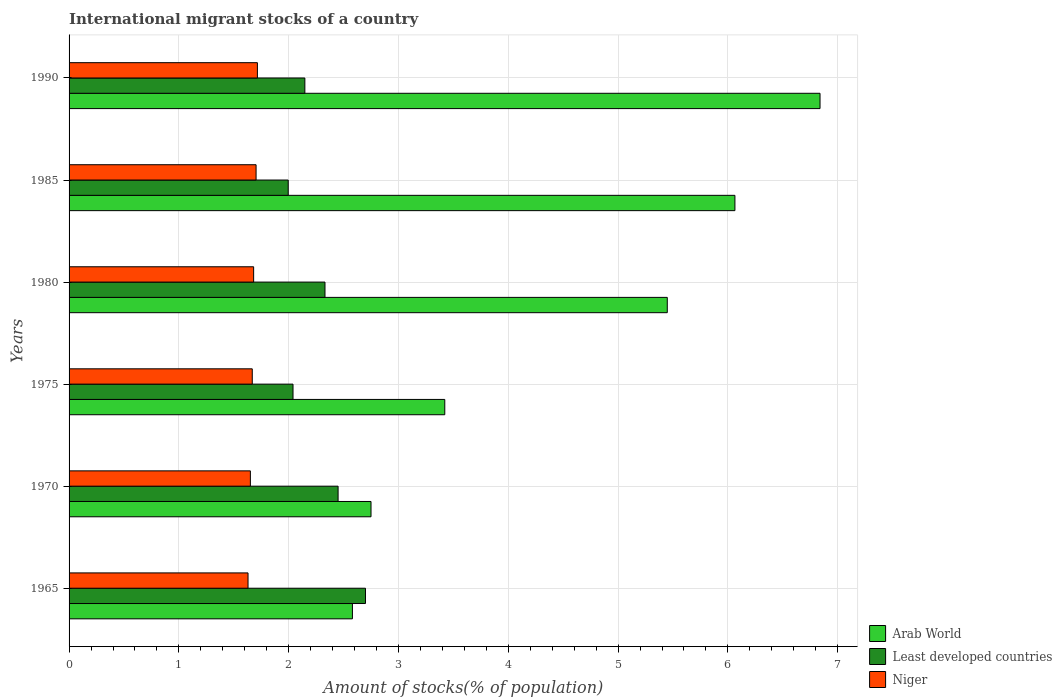How many different coloured bars are there?
Your response must be concise. 3. How many groups of bars are there?
Your answer should be very brief. 6. Are the number of bars per tick equal to the number of legend labels?
Offer a terse response. Yes. How many bars are there on the 1st tick from the bottom?
Make the answer very short. 3. What is the label of the 5th group of bars from the top?
Offer a terse response. 1970. What is the amount of stocks in in Arab World in 1990?
Provide a short and direct response. 6.84. Across all years, what is the maximum amount of stocks in in Arab World?
Ensure brevity in your answer.  6.84. Across all years, what is the minimum amount of stocks in in Least developed countries?
Provide a short and direct response. 2. In which year was the amount of stocks in in Least developed countries maximum?
Offer a terse response. 1965. In which year was the amount of stocks in in Least developed countries minimum?
Provide a short and direct response. 1985. What is the total amount of stocks in in Least developed countries in the graph?
Keep it short and to the point. 13.66. What is the difference between the amount of stocks in in Niger in 1985 and that in 1990?
Offer a very short reply. -0.01. What is the difference between the amount of stocks in in Niger in 1990 and the amount of stocks in in Arab World in 1975?
Provide a short and direct response. -1.71. What is the average amount of stocks in in Niger per year?
Provide a succinct answer. 1.67. In the year 1980, what is the difference between the amount of stocks in in Arab World and amount of stocks in in Least developed countries?
Ensure brevity in your answer.  3.12. What is the ratio of the amount of stocks in in Arab World in 1970 to that in 1980?
Offer a very short reply. 0.5. Is the difference between the amount of stocks in in Arab World in 1965 and 1985 greater than the difference between the amount of stocks in in Least developed countries in 1965 and 1985?
Ensure brevity in your answer.  No. What is the difference between the highest and the second highest amount of stocks in in Niger?
Provide a succinct answer. 0.01. What is the difference between the highest and the lowest amount of stocks in in Arab World?
Make the answer very short. 4.26. In how many years, is the amount of stocks in in Niger greater than the average amount of stocks in in Niger taken over all years?
Keep it short and to the point. 3. What does the 2nd bar from the top in 1985 represents?
Keep it short and to the point. Least developed countries. What does the 1st bar from the bottom in 1965 represents?
Provide a succinct answer. Arab World. How many bars are there?
Ensure brevity in your answer.  18. How many years are there in the graph?
Your answer should be very brief. 6. What is the difference between two consecutive major ticks on the X-axis?
Make the answer very short. 1. Where does the legend appear in the graph?
Your answer should be very brief. Bottom right. How many legend labels are there?
Provide a short and direct response. 3. How are the legend labels stacked?
Offer a terse response. Vertical. What is the title of the graph?
Your answer should be compact. International migrant stocks of a country. What is the label or title of the X-axis?
Your response must be concise. Amount of stocks(% of population). What is the label or title of the Y-axis?
Your answer should be very brief. Years. What is the Amount of stocks(% of population) of Arab World in 1965?
Offer a terse response. 2.58. What is the Amount of stocks(% of population) of Least developed countries in 1965?
Make the answer very short. 2.7. What is the Amount of stocks(% of population) in Niger in 1965?
Give a very brief answer. 1.63. What is the Amount of stocks(% of population) of Arab World in 1970?
Give a very brief answer. 2.75. What is the Amount of stocks(% of population) in Least developed countries in 1970?
Ensure brevity in your answer.  2.45. What is the Amount of stocks(% of population) of Niger in 1970?
Give a very brief answer. 1.65. What is the Amount of stocks(% of population) of Arab World in 1975?
Offer a terse response. 3.42. What is the Amount of stocks(% of population) of Least developed countries in 1975?
Your response must be concise. 2.04. What is the Amount of stocks(% of population) in Niger in 1975?
Offer a very short reply. 1.67. What is the Amount of stocks(% of population) of Arab World in 1980?
Keep it short and to the point. 5.45. What is the Amount of stocks(% of population) in Least developed countries in 1980?
Ensure brevity in your answer.  2.33. What is the Amount of stocks(% of population) of Niger in 1980?
Your answer should be compact. 1.68. What is the Amount of stocks(% of population) in Arab World in 1985?
Provide a succinct answer. 6.06. What is the Amount of stocks(% of population) of Least developed countries in 1985?
Offer a terse response. 2. What is the Amount of stocks(% of population) of Niger in 1985?
Ensure brevity in your answer.  1.7. What is the Amount of stocks(% of population) in Arab World in 1990?
Your answer should be compact. 6.84. What is the Amount of stocks(% of population) of Least developed countries in 1990?
Ensure brevity in your answer.  2.15. What is the Amount of stocks(% of population) in Niger in 1990?
Give a very brief answer. 1.72. Across all years, what is the maximum Amount of stocks(% of population) of Arab World?
Provide a short and direct response. 6.84. Across all years, what is the maximum Amount of stocks(% of population) in Least developed countries?
Provide a succinct answer. 2.7. Across all years, what is the maximum Amount of stocks(% of population) of Niger?
Your answer should be very brief. 1.72. Across all years, what is the minimum Amount of stocks(% of population) in Arab World?
Your answer should be very brief. 2.58. Across all years, what is the minimum Amount of stocks(% of population) in Least developed countries?
Offer a very short reply. 2. Across all years, what is the minimum Amount of stocks(% of population) in Niger?
Provide a short and direct response. 1.63. What is the total Amount of stocks(% of population) in Arab World in the graph?
Keep it short and to the point. 27.1. What is the total Amount of stocks(% of population) of Least developed countries in the graph?
Your answer should be very brief. 13.66. What is the total Amount of stocks(% of population) of Niger in the graph?
Offer a very short reply. 10.05. What is the difference between the Amount of stocks(% of population) of Arab World in 1965 and that in 1970?
Ensure brevity in your answer.  -0.17. What is the difference between the Amount of stocks(% of population) in Least developed countries in 1965 and that in 1970?
Provide a succinct answer. 0.25. What is the difference between the Amount of stocks(% of population) of Niger in 1965 and that in 1970?
Your answer should be very brief. -0.02. What is the difference between the Amount of stocks(% of population) in Arab World in 1965 and that in 1975?
Make the answer very short. -0.84. What is the difference between the Amount of stocks(% of population) in Least developed countries in 1965 and that in 1975?
Your answer should be compact. 0.66. What is the difference between the Amount of stocks(% of population) in Niger in 1965 and that in 1975?
Provide a short and direct response. -0.04. What is the difference between the Amount of stocks(% of population) of Arab World in 1965 and that in 1980?
Your response must be concise. -2.87. What is the difference between the Amount of stocks(% of population) of Least developed countries in 1965 and that in 1980?
Offer a terse response. 0.37. What is the difference between the Amount of stocks(% of population) in Niger in 1965 and that in 1980?
Give a very brief answer. -0.05. What is the difference between the Amount of stocks(% of population) in Arab World in 1965 and that in 1985?
Your answer should be very brief. -3.48. What is the difference between the Amount of stocks(% of population) in Least developed countries in 1965 and that in 1985?
Provide a succinct answer. 0.7. What is the difference between the Amount of stocks(% of population) in Niger in 1965 and that in 1985?
Give a very brief answer. -0.07. What is the difference between the Amount of stocks(% of population) of Arab World in 1965 and that in 1990?
Provide a succinct answer. -4.26. What is the difference between the Amount of stocks(% of population) of Least developed countries in 1965 and that in 1990?
Ensure brevity in your answer.  0.55. What is the difference between the Amount of stocks(% of population) of Niger in 1965 and that in 1990?
Offer a terse response. -0.09. What is the difference between the Amount of stocks(% of population) of Arab World in 1970 and that in 1975?
Ensure brevity in your answer.  -0.67. What is the difference between the Amount of stocks(% of population) of Least developed countries in 1970 and that in 1975?
Keep it short and to the point. 0.41. What is the difference between the Amount of stocks(% of population) of Niger in 1970 and that in 1975?
Your answer should be very brief. -0.02. What is the difference between the Amount of stocks(% of population) of Arab World in 1970 and that in 1980?
Your answer should be compact. -2.7. What is the difference between the Amount of stocks(% of population) in Least developed countries in 1970 and that in 1980?
Your answer should be very brief. 0.12. What is the difference between the Amount of stocks(% of population) in Niger in 1970 and that in 1980?
Provide a short and direct response. -0.03. What is the difference between the Amount of stocks(% of population) of Arab World in 1970 and that in 1985?
Your response must be concise. -3.31. What is the difference between the Amount of stocks(% of population) in Least developed countries in 1970 and that in 1985?
Ensure brevity in your answer.  0.45. What is the difference between the Amount of stocks(% of population) of Niger in 1970 and that in 1985?
Your answer should be very brief. -0.05. What is the difference between the Amount of stocks(% of population) of Arab World in 1970 and that in 1990?
Your response must be concise. -4.09. What is the difference between the Amount of stocks(% of population) of Least developed countries in 1970 and that in 1990?
Offer a terse response. 0.3. What is the difference between the Amount of stocks(% of population) in Niger in 1970 and that in 1990?
Offer a very short reply. -0.06. What is the difference between the Amount of stocks(% of population) in Arab World in 1975 and that in 1980?
Provide a succinct answer. -2.03. What is the difference between the Amount of stocks(% of population) in Least developed countries in 1975 and that in 1980?
Provide a short and direct response. -0.29. What is the difference between the Amount of stocks(% of population) in Niger in 1975 and that in 1980?
Ensure brevity in your answer.  -0.01. What is the difference between the Amount of stocks(% of population) in Arab World in 1975 and that in 1985?
Offer a terse response. -2.64. What is the difference between the Amount of stocks(% of population) in Least developed countries in 1975 and that in 1985?
Offer a terse response. 0.04. What is the difference between the Amount of stocks(% of population) of Niger in 1975 and that in 1985?
Your response must be concise. -0.03. What is the difference between the Amount of stocks(% of population) of Arab World in 1975 and that in 1990?
Make the answer very short. -3.42. What is the difference between the Amount of stocks(% of population) of Least developed countries in 1975 and that in 1990?
Provide a succinct answer. -0.11. What is the difference between the Amount of stocks(% of population) of Niger in 1975 and that in 1990?
Ensure brevity in your answer.  -0.05. What is the difference between the Amount of stocks(% of population) in Arab World in 1980 and that in 1985?
Provide a short and direct response. -0.62. What is the difference between the Amount of stocks(% of population) in Least developed countries in 1980 and that in 1985?
Provide a succinct answer. 0.33. What is the difference between the Amount of stocks(% of population) in Niger in 1980 and that in 1985?
Your response must be concise. -0.02. What is the difference between the Amount of stocks(% of population) of Arab World in 1980 and that in 1990?
Offer a terse response. -1.39. What is the difference between the Amount of stocks(% of population) of Least developed countries in 1980 and that in 1990?
Provide a succinct answer. 0.18. What is the difference between the Amount of stocks(% of population) in Niger in 1980 and that in 1990?
Your answer should be very brief. -0.03. What is the difference between the Amount of stocks(% of population) of Arab World in 1985 and that in 1990?
Give a very brief answer. -0.78. What is the difference between the Amount of stocks(% of population) in Least developed countries in 1985 and that in 1990?
Offer a very short reply. -0.15. What is the difference between the Amount of stocks(% of population) in Niger in 1985 and that in 1990?
Offer a terse response. -0.01. What is the difference between the Amount of stocks(% of population) in Arab World in 1965 and the Amount of stocks(% of population) in Least developed countries in 1970?
Provide a short and direct response. 0.13. What is the difference between the Amount of stocks(% of population) in Arab World in 1965 and the Amount of stocks(% of population) in Niger in 1970?
Offer a very short reply. 0.93. What is the difference between the Amount of stocks(% of population) in Least developed countries in 1965 and the Amount of stocks(% of population) in Niger in 1970?
Your answer should be compact. 1.05. What is the difference between the Amount of stocks(% of population) of Arab World in 1965 and the Amount of stocks(% of population) of Least developed countries in 1975?
Your response must be concise. 0.54. What is the difference between the Amount of stocks(% of population) of Arab World in 1965 and the Amount of stocks(% of population) of Niger in 1975?
Your answer should be very brief. 0.91. What is the difference between the Amount of stocks(% of population) of Least developed countries in 1965 and the Amount of stocks(% of population) of Niger in 1975?
Your answer should be very brief. 1.03. What is the difference between the Amount of stocks(% of population) in Arab World in 1965 and the Amount of stocks(% of population) in Least developed countries in 1980?
Offer a terse response. 0.25. What is the difference between the Amount of stocks(% of population) of Arab World in 1965 and the Amount of stocks(% of population) of Niger in 1980?
Your answer should be very brief. 0.9. What is the difference between the Amount of stocks(% of population) of Least developed countries in 1965 and the Amount of stocks(% of population) of Niger in 1980?
Offer a very short reply. 1.02. What is the difference between the Amount of stocks(% of population) in Arab World in 1965 and the Amount of stocks(% of population) in Least developed countries in 1985?
Ensure brevity in your answer.  0.58. What is the difference between the Amount of stocks(% of population) of Arab World in 1965 and the Amount of stocks(% of population) of Niger in 1985?
Give a very brief answer. 0.88. What is the difference between the Amount of stocks(% of population) of Arab World in 1965 and the Amount of stocks(% of population) of Least developed countries in 1990?
Your answer should be compact. 0.43. What is the difference between the Amount of stocks(% of population) of Arab World in 1965 and the Amount of stocks(% of population) of Niger in 1990?
Your answer should be very brief. 0.87. What is the difference between the Amount of stocks(% of population) in Least developed countries in 1965 and the Amount of stocks(% of population) in Niger in 1990?
Ensure brevity in your answer.  0.98. What is the difference between the Amount of stocks(% of population) of Arab World in 1970 and the Amount of stocks(% of population) of Least developed countries in 1975?
Provide a short and direct response. 0.71. What is the difference between the Amount of stocks(% of population) of Arab World in 1970 and the Amount of stocks(% of population) of Niger in 1975?
Provide a succinct answer. 1.08. What is the difference between the Amount of stocks(% of population) in Least developed countries in 1970 and the Amount of stocks(% of population) in Niger in 1975?
Give a very brief answer. 0.78. What is the difference between the Amount of stocks(% of population) of Arab World in 1970 and the Amount of stocks(% of population) of Least developed countries in 1980?
Give a very brief answer. 0.42. What is the difference between the Amount of stocks(% of population) of Arab World in 1970 and the Amount of stocks(% of population) of Niger in 1980?
Provide a succinct answer. 1.07. What is the difference between the Amount of stocks(% of population) of Least developed countries in 1970 and the Amount of stocks(% of population) of Niger in 1980?
Give a very brief answer. 0.77. What is the difference between the Amount of stocks(% of population) in Arab World in 1970 and the Amount of stocks(% of population) in Least developed countries in 1985?
Ensure brevity in your answer.  0.75. What is the difference between the Amount of stocks(% of population) of Arab World in 1970 and the Amount of stocks(% of population) of Niger in 1985?
Ensure brevity in your answer.  1.05. What is the difference between the Amount of stocks(% of population) in Least developed countries in 1970 and the Amount of stocks(% of population) in Niger in 1985?
Your response must be concise. 0.75. What is the difference between the Amount of stocks(% of population) of Arab World in 1970 and the Amount of stocks(% of population) of Least developed countries in 1990?
Offer a very short reply. 0.6. What is the difference between the Amount of stocks(% of population) of Arab World in 1970 and the Amount of stocks(% of population) of Niger in 1990?
Give a very brief answer. 1.03. What is the difference between the Amount of stocks(% of population) in Least developed countries in 1970 and the Amount of stocks(% of population) in Niger in 1990?
Keep it short and to the point. 0.73. What is the difference between the Amount of stocks(% of population) in Arab World in 1975 and the Amount of stocks(% of population) in Least developed countries in 1980?
Your answer should be very brief. 1.09. What is the difference between the Amount of stocks(% of population) of Arab World in 1975 and the Amount of stocks(% of population) of Niger in 1980?
Make the answer very short. 1.74. What is the difference between the Amount of stocks(% of population) of Least developed countries in 1975 and the Amount of stocks(% of population) of Niger in 1980?
Offer a very short reply. 0.36. What is the difference between the Amount of stocks(% of population) of Arab World in 1975 and the Amount of stocks(% of population) of Least developed countries in 1985?
Provide a short and direct response. 1.43. What is the difference between the Amount of stocks(% of population) of Arab World in 1975 and the Amount of stocks(% of population) of Niger in 1985?
Offer a terse response. 1.72. What is the difference between the Amount of stocks(% of population) in Least developed countries in 1975 and the Amount of stocks(% of population) in Niger in 1985?
Provide a short and direct response. 0.34. What is the difference between the Amount of stocks(% of population) in Arab World in 1975 and the Amount of stocks(% of population) in Least developed countries in 1990?
Give a very brief answer. 1.27. What is the difference between the Amount of stocks(% of population) in Arab World in 1975 and the Amount of stocks(% of population) in Niger in 1990?
Your answer should be very brief. 1.71. What is the difference between the Amount of stocks(% of population) of Least developed countries in 1975 and the Amount of stocks(% of population) of Niger in 1990?
Keep it short and to the point. 0.32. What is the difference between the Amount of stocks(% of population) in Arab World in 1980 and the Amount of stocks(% of population) in Least developed countries in 1985?
Your response must be concise. 3.45. What is the difference between the Amount of stocks(% of population) in Arab World in 1980 and the Amount of stocks(% of population) in Niger in 1985?
Offer a terse response. 3.74. What is the difference between the Amount of stocks(% of population) in Least developed countries in 1980 and the Amount of stocks(% of population) in Niger in 1985?
Give a very brief answer. 0.63. What is the difference between the Amount of stocks(% of population) of Arab World in 1980 and the Amount of stocks(% of population) of Least developed countries in 1990?
Give a very brief answer. 3.3. What is the difference between the Amount of stocks(% of population) in Arab World in 1980 and the Amount of stocks(% of population) in Niger in 1990?
Make the answer very short. 3.73. What is the difference between the Amount of stocks(% of population) in Least developed countries in 1980 and the Amount of stocks(% of population) in Niger in 1990?
Keep it short and to the point. 0.62. What is the difference between the Amount of stocks(% of population) in Arab World in 1985 and the Amount of stocks(% of population) in Least developed countries in 1990?
Offer a terse response. 3.92. What is the difference between the Amount of stocks(% of population) of Arab World in 1985 and the Amount of stocks(% of population) of Niger in 1990?
Make the answer very short. 4.35. What is the difference between the Amount of stocks(% of population) in Least developed countries in 1985 and the Amount of stocks(% of population) in Niger in 1990?
Your response must be concise. 0.28. What is the average Amount of stocks(% of population) of Arab World per year?
Your answer should be compact. 4.52. What is the average Amount of stocks(% of population) of Least developed countries per year?
Make the answer very short. 2.28. What is the average Amount of stocks(% of population) of Niger per year?
Your answer should be compact. 1.67. In the year 1965, what is the difference between the Amount of stocks(% of population) of Arab World and Amount of stocks(% of population) of Least developed countries?
Ensure brevity in your answer.  -0.12. In the year 1965, what is the difference between the Amount of stocks(% of population) in Arab World and Amount of stocks(% of population) in Niger?
Make the answer very short. 0.95. In the year 1965, what is the difference between the Amount of stocks(% of population) of Least developed countries and Amount of stocks(% of population) of Niger?
Offer a very short reply. 1.07. In the year 1970, what is the difference between the Amount of stocks(% of population) of Arab World and Amount of stocks(% of population) of Least developed countries?
Your answer should be compact. 0.3. In the year 1970, what is the difference between the Amount of stocks(% of population) in Arab World and Amount of stocks(% of population) in Niger?
Your response must be concise. 1.1. In the year 1970, what is the difference between the Amount of stocks(% of population) of Least developed countries and Amount of stocks(% of population) of Niger?
Give a very brief answer. 0.8. In the year 1975, what is the difference between the Amount of stocks(% of population) of Arab World and Amount of stocks(% of population) of Least developed countries?
Your response must be concise. 1.38. In the year 1975, what is the difference between the Amount of stocks(% of population) of Arab World and Amount of stocks(% of population) of Niger?
Provide a succinct answer. 1.75. In the year 1975, what is the difference between the Amount of stocks(% of population) in Least developed countries and Amount of stocks(% of population) in Niger?
Keep it short and to the point. 0.37. In the year 1980, what is the difference between the Amount of stocks(% of population) of Arab World and Amount of stocks(% of population) of Least developed countries?
Provide a succinct answer. 3.12. In the year 1980, what is the difference between the Amount of stocks(% of population) in Arab World and Amount of stocks(% of population) in Niger?
Offer a very short reply. 3.77. In the year 1980, what is the difference between the Amount of stocks(% of population) of Least developed countries and Amount of stocks(% of population) of Niger?
Provide a short and direct response. 0.65. In the year 1985, what is the difference between the Amount of stocks(% of population) in Arab World and Amount of stocks(% of population) in Least developed countries?
Your answer should be very brief. 4.07. In the year 1985, what is the difference between the Amount of stocks(% of population) in Arab World and Amount of stocks(% of population) in Niger?
Give a very brief answer. 4.36. In the year 1985, what is the difference between the Amount of stocks(% of population) in Least developed countries and Amount of stocks(% of population) in Niger?
Ensure brevity in your answer.  0.29. In the year 1990, what is the difference between the Amount of stocks(% of population) in Arab World and Amount of stocks(% of population) in Least developed countries?
Your answer should be compact. 4.69. In the year 1990, what is the difference between the Amount of stocks(% of population) in Arab World and Amount of stocks(% of population) in Niger?
Make the answer very short. 5.12. In the year 1990, what is the difference between the Amount of stocks(% of population) of Least developed countries and Amount of stocks(% of population) of Niger?
Your answer should be very brief. 0.43. What is the ratio of the Amount of stocks(% of population) in Arab World in 1965 to that in 1970?
Offer a terse response. 0.94. What is the ratio of the Amount of stocks(% of population) of Least developed countries in 1965 to that in 1970?
Provide a short and direct response. 1.1. What is the ratio of the Amount of stocks(% of population) of Niger in 1965 to that in 1970?
Give a very brief answer. 0.99. What is the ratio of the Amount of stocks(% of population) of Arab World in 1965 to that in 1975?
Offer a very short reply. 0.75. What is the ratio of the Amount of stocks(% of population) in Least developed countries in 1965 to that in 1975?
Your answer should be compact. 1.32. What is the ratio of the Amount of stocks(% of population) in Niger in 1965 to that in 1975?
Provide a short and direct response. 0.98. What is the ratio of the Amount of stocks(% of population) in Arab World in 1965 to that in 1980?
Provide a succinct answer. 0.47. What is the ratio of the Amount of stocks(% of population) in Least developed countries in 1965 to that in 1980?
Make the answer very short. 1.16. What is the ratio of the Amount of stocks(% of population) of Niger in 1965 to that in 1980?
Your answer should be compact. 0.97. What is the ratio of the Amount of stocks(% of population) in Arab World in 1965 to that in 1985?
Provide a succinct answer. 0.43. What is the ratio of the Amount of stocks(% of population) of Least developed countries in 1965 to that in 1985?
Give a very brief answer. 1.35. What is the ratio of the Amount of stocks(% of population) in Niger in 1965 to that in 1985?
Make the answer very short. 0.96. What is the ratio of the Amount of stocks(% of population) of Arab World in 1965 to that in 1990?
Give a very brief answer. 0.38. What is the ratio of the Amount of stocks(% of population) in Least developed countries in 1965 to that in 1990?
Provide a short and direct response. 1.26. What is the ratio of the Amount of stocks(% of population) in Niger in 1965 to that in 1990?
Offer a terse response. 0.95. What is the ratio of the Amount of stocks(% of population) of Arab World in 1970 to that in 1975?
Provide a short and direct response. 0.8. What is the ratio of the Amount of stocks(% of population) of Least developed countries in 1970 to that in 1975?
Offer a terse response. 1.2. What is the ratio of the Amount of stocks(% of population) in Niger in 1970 to that in 1975?
Offer a very short reply. 0.99. What is the ratio of the Amount of stocks(% of population) of Arab World in 1970 to that in 1980?
Provide a short and direct response. 0.5. What is the ratio of the Amount of stocks(% of population) in Least developed countries in 1970 to that in 1980?
Offer a very short reply. 1.05. What is the ratio of the Amount of stocks(% of population) in Niger in 1970 to that in 1980?
Provide a short and direct response. 0.98. What is the ratio of the Amount of stocks(% of population) of Arab World in 1970 to that in 1985?
Offer a very short reply. 0.45. What is the ratio of the Amount of stocks(% of population) of Least developed countries in 1970 to that in 1985?
Keep it short and to the point. 1.23. What is the ratio of the Amount of stocks(% of population) of Niger in 1970 to that in 1985?
Your answer should be compact. 0.97. What is the ratio of the Amount of stocks(% of population) in Arab World in 1970 to that in 1990?
Make the answer very short. 0.4. What is the ratio of the Amount of stocks(% of population) in Least developed countries in 1970 to that in 1990?
Offer a terse response. 1.14. What is the ratio of the Amount of stocks(% of population) in Niger in 1970 to that in 1990?
Your response must be concise. 0.96. What is the ratio of the Amount of stocks(% of population) in Arab World in 1975 to that in 1980?
Offer a terse response. 0.63. What is the ratio of the Amount of stocks(% of population) of Least developed countries in 1975 to that in 1980?
Your response must be concise. 0.88. What is the ratio of the Amount of stocks(% of population) in Niger in 1975 to that in 1980?
Provide a short and direct response. 0.99. What is the ratio of the Amount of stocks(% of population) of Arab World in 1975 to that in 1985?
Offer a very short reply. 0.56. What is the ratio of the Amount of stocks(% of population) of Least developed countries in 1975 to that in 1985?
Offer a terse response. 1.02. What is the ratio of the Amount of stocks(% of population) of Niger in 1975 to that in 1985?
Ensure brevity in your answer.  0.98. What is the ratio of the Amount of stocks(% of population) in Arab World in 1975 to that in 1990?
Offer a terse response. 0.5. What is the ratio of the Amount of stocks(% of population) of Least developed countries in 1975 to that in 1990?
Your response must be concise. 0.95. What is the ratio of the Amount of stocks(% of population) of Niger in 1975 to that in 1990?
Offer a terse response. 0.97. What is the ratio of the Amount of stocks(% of population) in Arab World in 1980 to that in 1985?
Give a very brief answer. 0.9. What is the ratio of the Amount of stocks(% of population) in Least developed countries in 1980 to that in 1985?
Ensure brevity in your answer.  1.17. What is the ratio of the Amount of stocks(% of population) of Niger in 1980 to that in 1985?
Keep it short and to the point. 0.99. What is the ratio of the Amount of stocks(% of population) of Arab World in 1980 to that in 1990?
Offer a very short reply. 0.8. What is the ratio of the Amount of stocks(% of population) in Least developed countries in 1980 to that in 1990?
Ensure brevity in your answer.  1.09. What is the ratio of the Amount of stocks(% of population) of Arab World in 1985 to that in 1990?
Keep it short and to the point. 0.89. What is the ratio of the Amount of stocks(% of population) of Least developed countries in 1985 to that in 1990?
Your answer should be compact. 0.93. What is the difference between the highest and the second highest Amount of stocks(% of population) in Arab World?
Offer a very short reply. 0.78. What is the difference between the highest and the second highest Amount of stocks(% of population) of Least developed countries?
Provide a succinct answer. 0.25. What is the difference between the highest and the second highest Amount of stocks(% of population) in Niger?
Provide a succinct answer. 0.01. What is the difference between the highest and the lowest Amount of stocks(% of population) of Arab World?
Your response must be concise. 4.26. What is the difference between the highest and the lowest Amount of stocks(% of population) of Least developed countries?
Ensure brevity in your answer.  0.7. What is the difference between the highest and the lowest Amount of stocks(% of population) in Niger?
Your response must be concise. 0.09. 